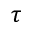Convert formula to latex. <formula><loc_0><loc_0><loc_500><loc_500>\tau</formula> 